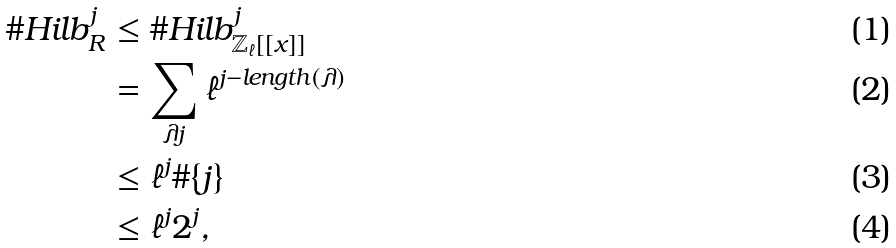Convert formula to latex. <formula><loc_0><loc_0><loc_500><loc_500>\# H i l b _ { R } ^ { j } & \leq \# H i l b _ { \mathbb { Z } _ { \ell } [ [ x ] ] } ^ { j } \\ & = \sum _ { \lambda j } \ell ^ { j - l e n g t h ( \lambda ) } \\ & \leq \ell ^ { j } \# \{ j \} \\ & \leq \ell ^ { j } 2 ^ { j } ,</formula> 